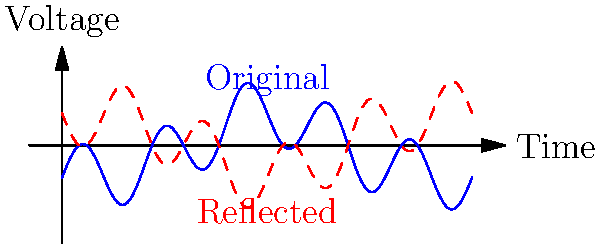In the ECG waveform shown above, a reflection across the x-axis has been performed. How does this transformation affect the interpretation of potential arrhythmias, particularly in relation to the T wave morphology? To understand the effect of reflection on ECG interpretation, let's follow these steps:

1. Normal ECG waveform:
   - The original blue waveform represents a typical ECG pattern.
   - The T wave is normally upright (positive) in most leads.

2. Reflection transformation:
   - The red dashed line shows the waveform reflected across the x-axis.
   - This transformation inverts all components of the ECG.

3. T wave changes:
   - In the original waveform, the T wave is positive (pointing upward).
   - After reflection, the T wave becomes negative (pointing downward).

4. Interpretation of inverted T waves:
   - Inverted T waves can indicate various cardiac abnormalities, including:
     a) Myocardial ischemia or infarction
     b) Ventricular hypertrophy
     c) Bundle branch blocks
     d) Electrolyte imbalances (e.g., hyperkalemia)

5. Impact on arrhythmia diagnosis:
   - The reflection could lead to misinterpretation of:
     a) ST-segment elevation or depression
     b) QT interval prolongation or shortening
     c) U wave abnormalities

6. Clinical significance:
   - In practice, an inverted ECG would be immediately recognized as abnormal.
   - Correct lead placement and proper ECG recording are crucial to avoid such errors.

7. Importance in cardiology:
   - Understanding the effects of waveform transformations is essential for:
     a) Recognizing technical errors in ECG recording
     b) Interpreting ECGs from different lead systems
     c) Analyzing vectorcardiograms

In conclusion, reflecting an ECG waveform across the x-axis inverts all components, potentially leading to misinterpretation of arrhythmias and other cardiac abnormalities if not recognized as a technical error or intentional transformation.
Answer: Inversion of T wave polarity, potentially misinterpreting normal findings as pathological (e.g., ischemia, electrolyte imbalances) if not recognized as a reflection. 